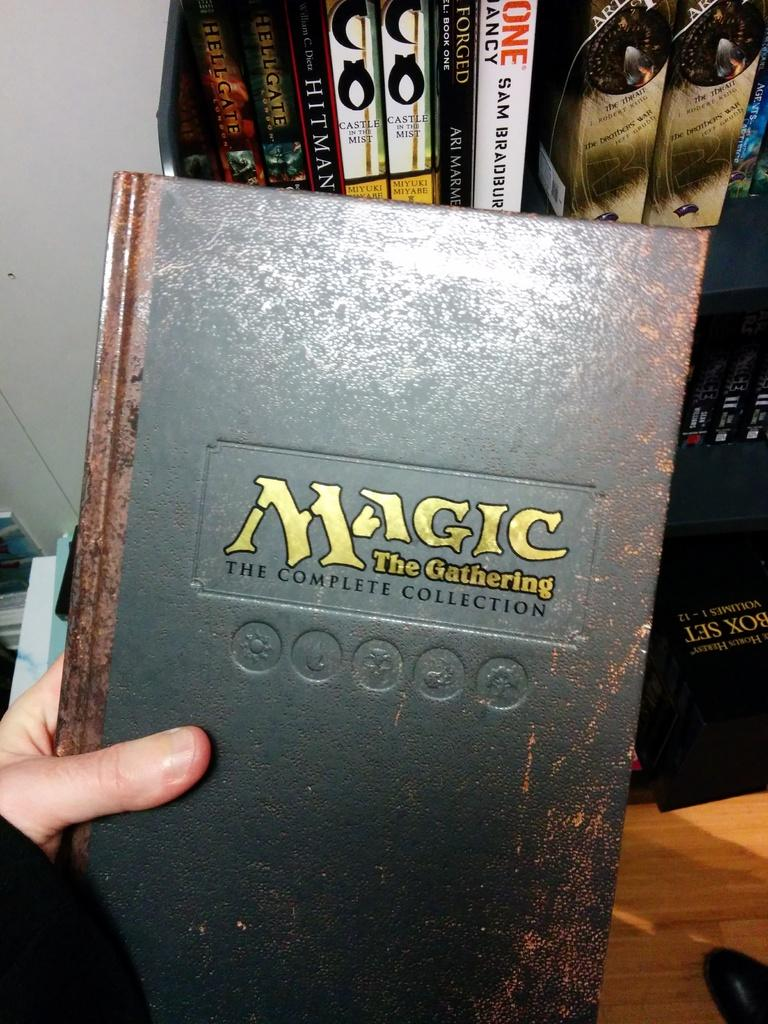Provide a one-sentence caption for the provided image. Magic the gathering the complete collection book in somebody hand. 